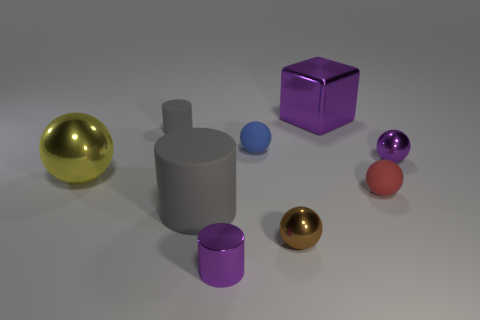There is a object that is both behind the blue object and on the left side of the big metallic block; what is its shape? cylinder 